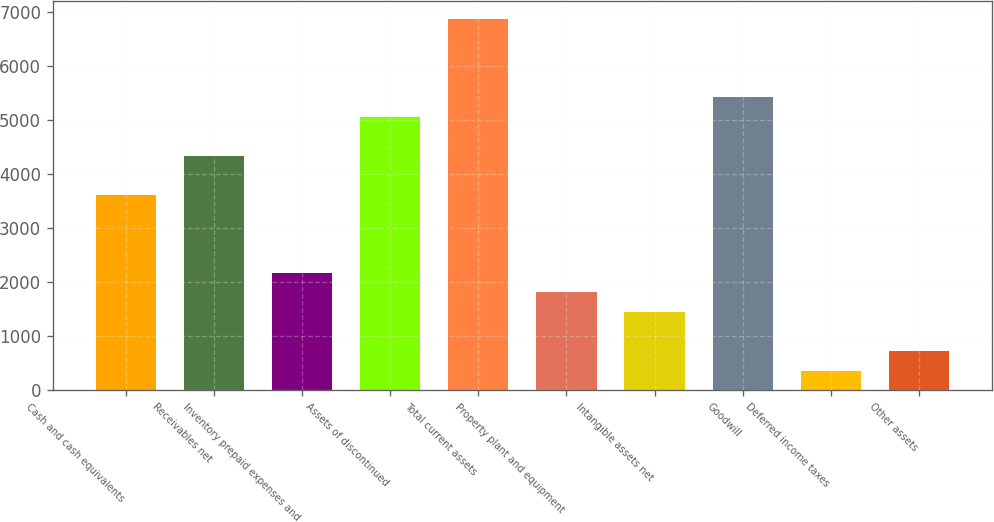Convert chart. <chart><loc_0><loc_0><loc_500><loc_500><bar_chart><fcel>Cash and cash equivalents<fcel>Receivables net<fcel>Inventory prepaid expenses and<fcel>Assets of discontinued<fcel>Total current assets<fcel>Property plant and equipment<fcel>Intangible assets net<fcel>Goodwill<fcel>Deferred income taxes<fcel>Other assets<nl><fcel>3617<fcel>4340<fcel>2171<fcel>5063<fcel>6870.5<fcel>1809.5<fcel>1448<fcel>5424.5<fcel>363.5<fcel>725<nl></chart> 